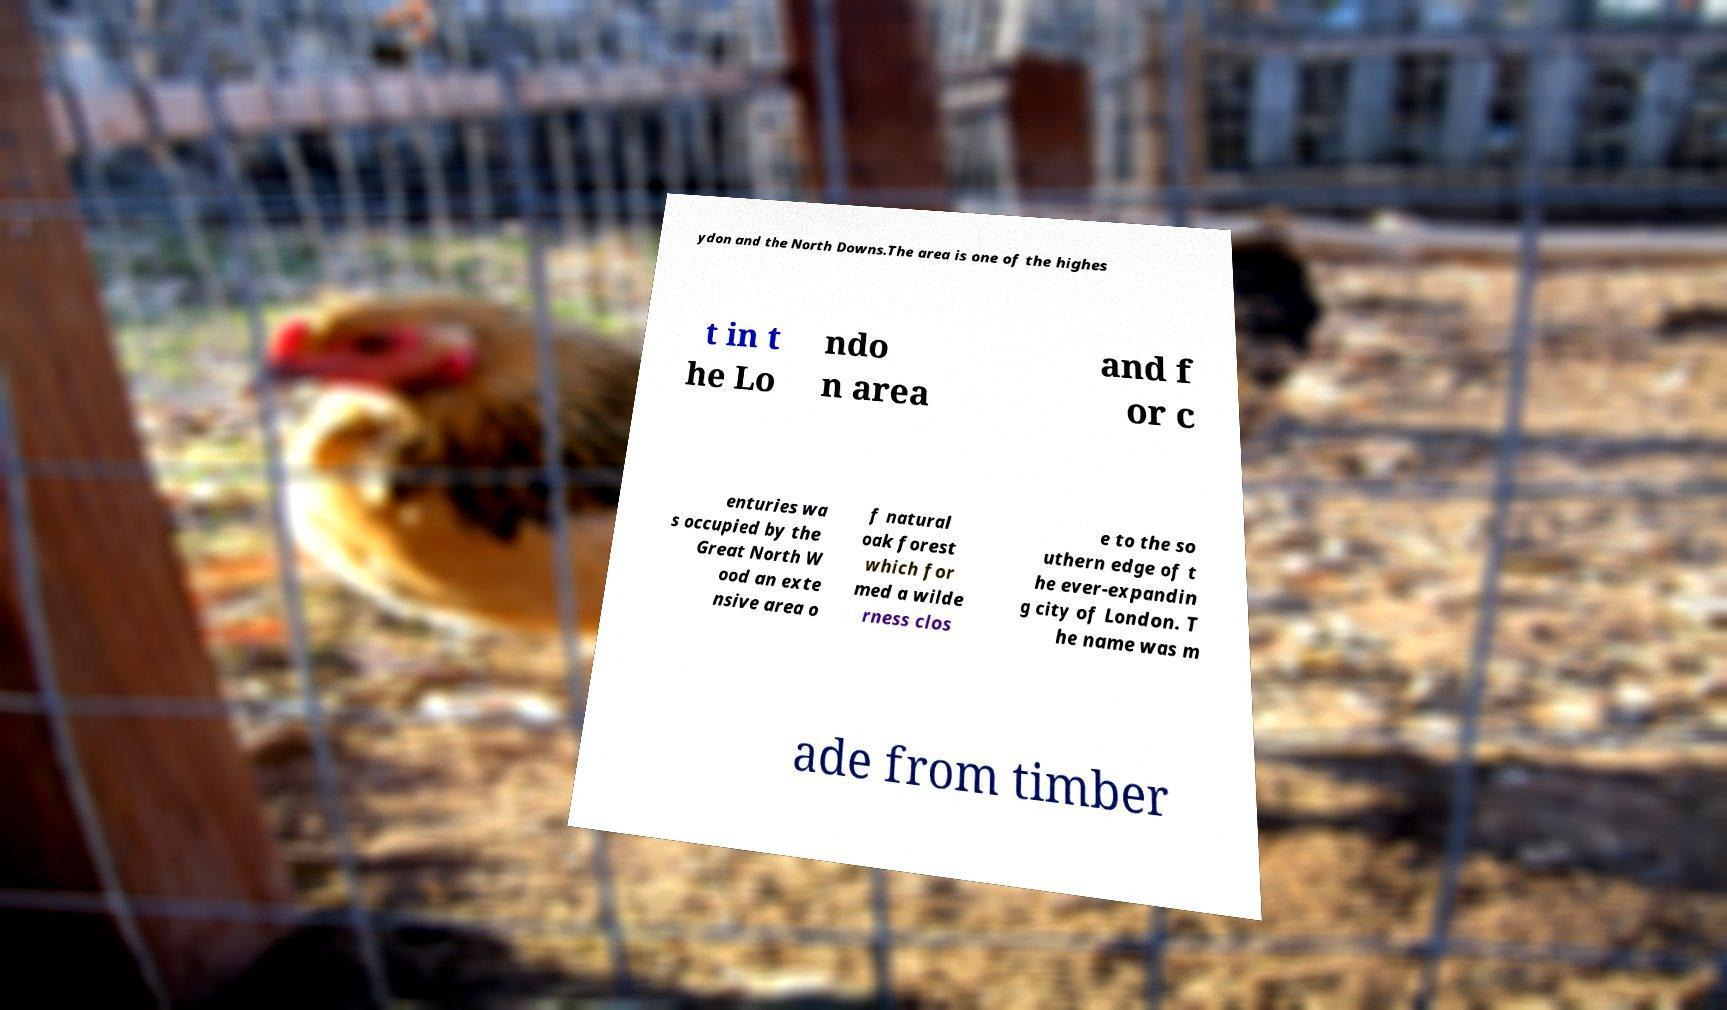Could you assist in decoding the text presented in this image and type it out clearly? ydon and the North Downs.The area is one of the highes t in t he Lo ndo n area and f or c enturies wa s occupied by the Great North W ood an exte nsive area o f natural oak forest which for med a wilde rness clos e to the so uthern edge of t he ever-expandin g city of London. T he name was m ade from timber 